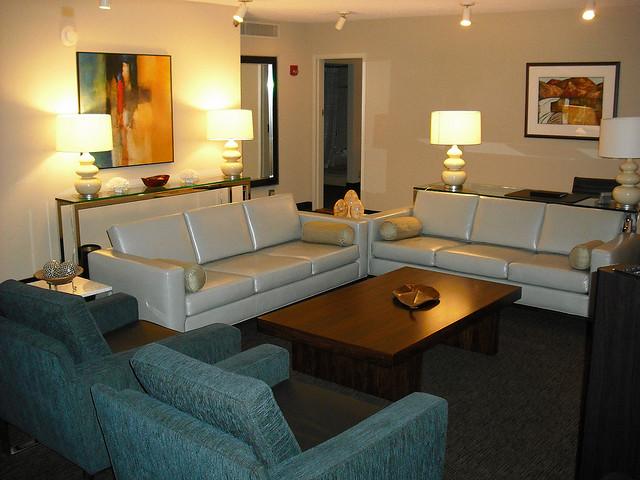What kind of picture is on the wall above the couch?
Short answer required. Abstract painting. Are all the lamps lit?
Short answer required. No. How many lamps are on?
Write a very short answer. 3. What room is this?
Write a very short answer. Living room. Where is the fire alarm?
Short answer required. On wall. How many sofas are in the room?
Quick response, please. 2. Is there tiling on the floor?
Concise answer only. No. How many pillows are pictured?
Give a very brief answer. 4. What makes it possible to see light shine on the carpet?
Write a very short answer. Lamps. 